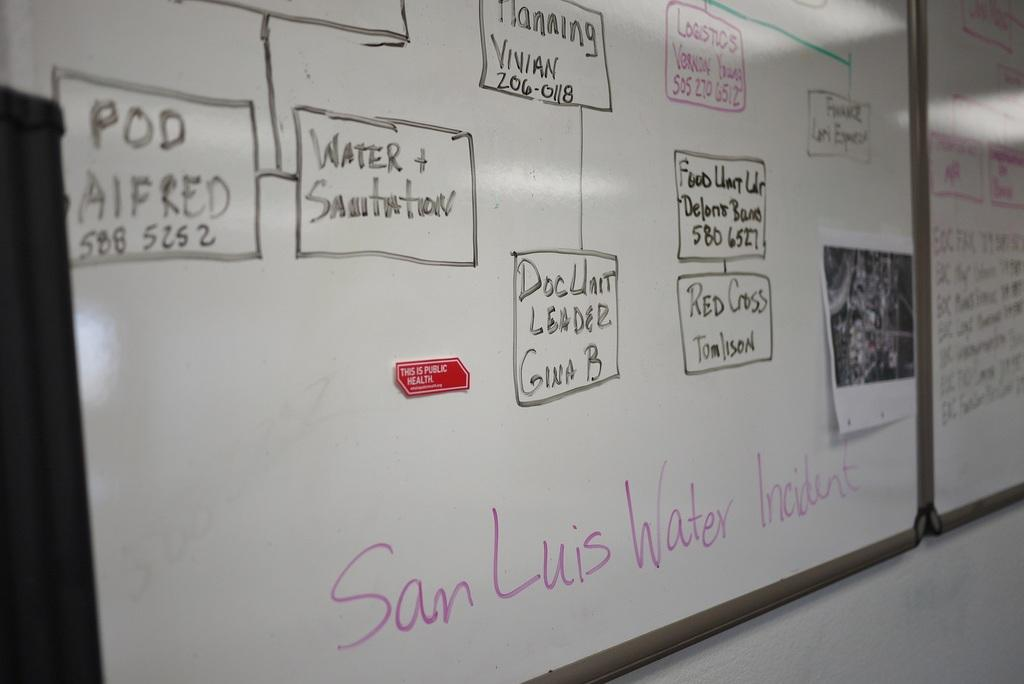<image>
Present a compact description of the photo's key features. the word san luis water is on a white board 